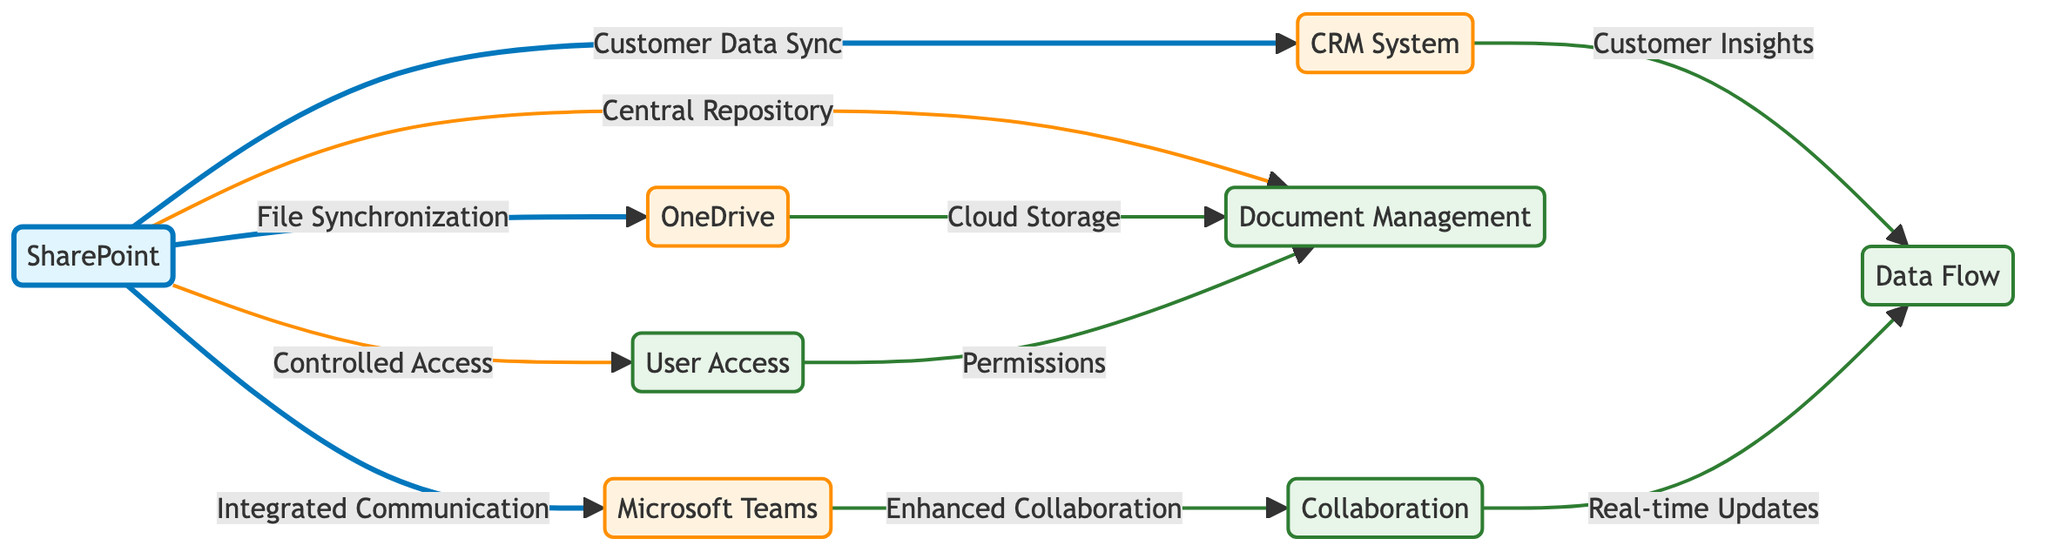What are the main applications integrated with SharePoint? The diagram displays three primary applications linked to SharePoint: Microsoft Teams, OneDrive, and a CRM System. These applications show the integration pathways utilized for enhanced functionality.
Answer: Microsoft Teams, OneDrive, CRM System What type of synchronization occurs between SharePoint and OneDrive? The diagram indicates that SharePoint interfaces with OneDrive through file synchronization, meaning files can be updated and stored between the two systems efficiently.
Answer: File Synchronization How does Microsoft Teams enhance the document management process? The diagram shows that Microsoft Teams contributes to enhanced collaboration, which plays a significant role in the overall document management process by providing a platform for team interactions and file sharing.
Answer: Enhanced Collaboration What is the primary function of SharePoint related to user access? The diagram illustrates that SharePoint provides controlled access, ensuring that user permissions are managed effectively for security and collaboration.
Answer: Controlled Access How many secondary applications are connected to SharePoint? The diagram lists three secondary applications that connect with SharePoint, which can be counted directly from the visual representation.
Answer: Three What is the relationship between CRM System and Data Flow in the diagram? According to the diagram, the CRM System delivers customer insights, which feed into the data flow, suggesting an integration that enriches overall data management.
Answer: Customer Insights What does User Access contribute to Document Management in SharePoint? The diagram illustrates that user access relates directly to permissions, indicating that the way users are granted access is crucial for proper document management practices.
Answer: Permissions Which component is central to both OneDrive and Document Management? The diagram shows that OneDrive provides cloud storage which intersects with the document management systems, indicating that both rely on centralized data storage for functionality.
Answer: Document Management 